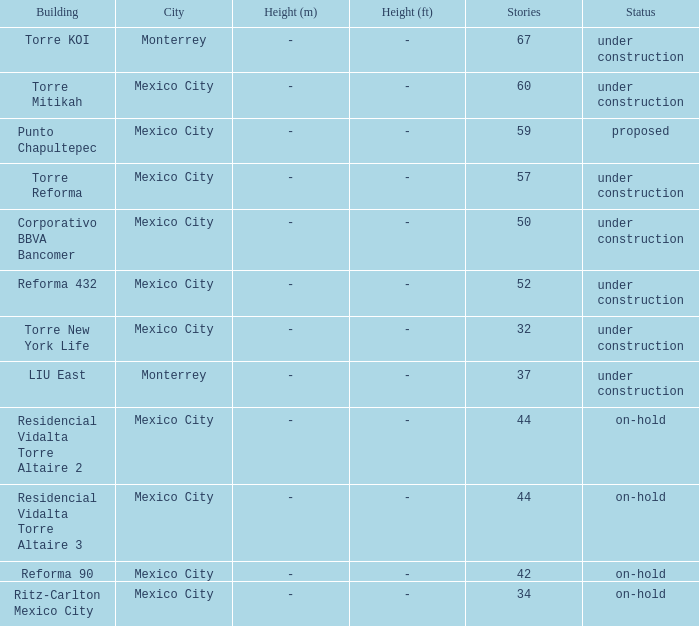What is the state of the torre reforma edifice that has above 44 stories in mexico city? Under construction. 